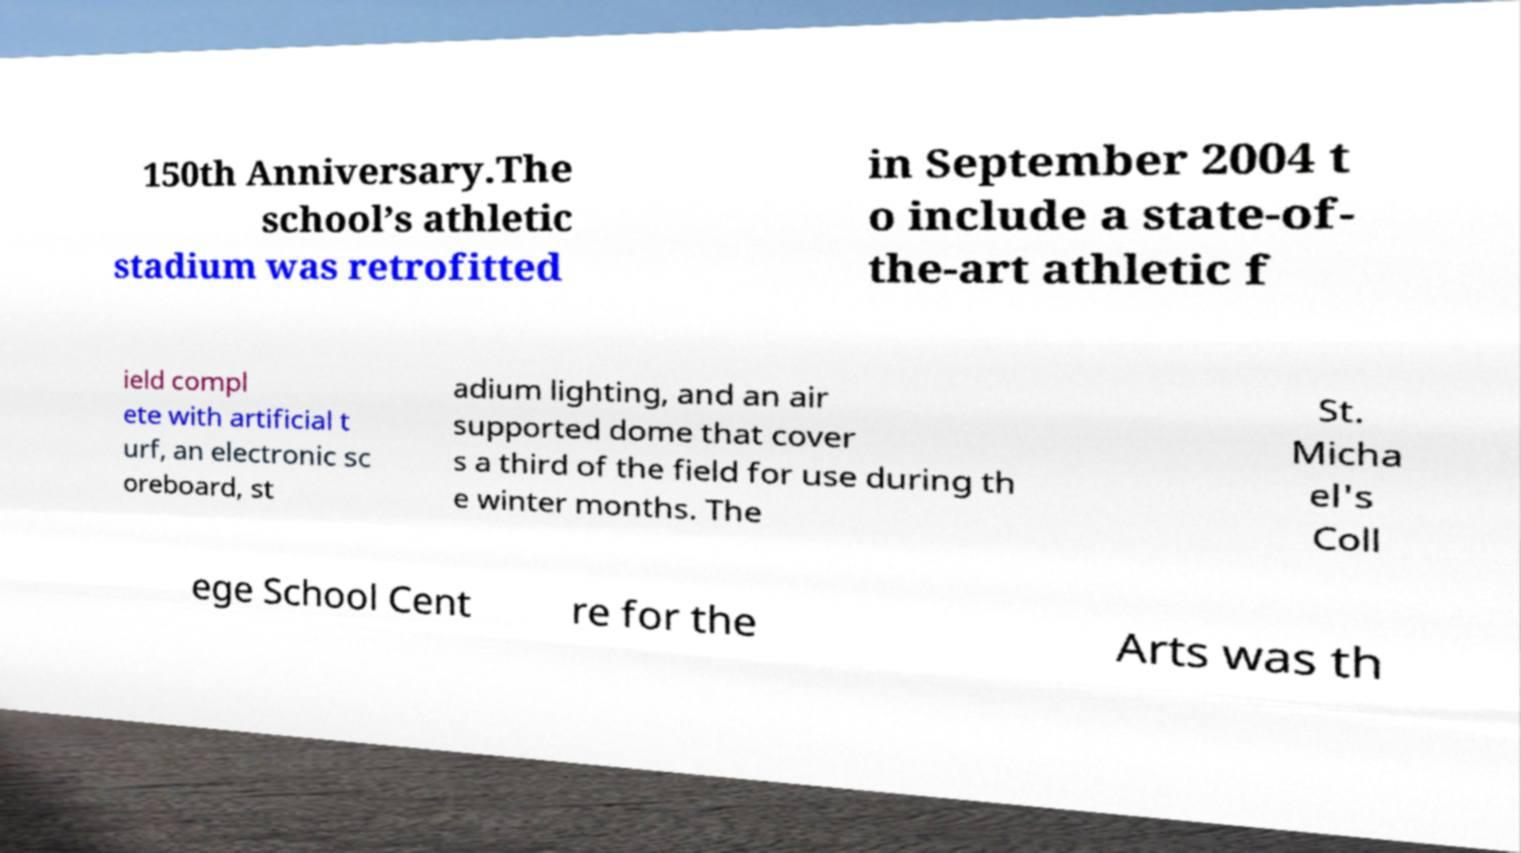There's text embedded in this image that I need extracted. Can you transcribe it verbatim? 150th Anniversary.The school’s athletic stadium was retrofitted in September 2004 t o include a state-of- the-art athletic f ield compl ete with artificial t urf, an electronic sc oreboard, st adium lighting, and an air supported dome that cover s a third of the field for use during th e winter months. The St. Micha el's Coll ege School Cent re for the Arts was th 